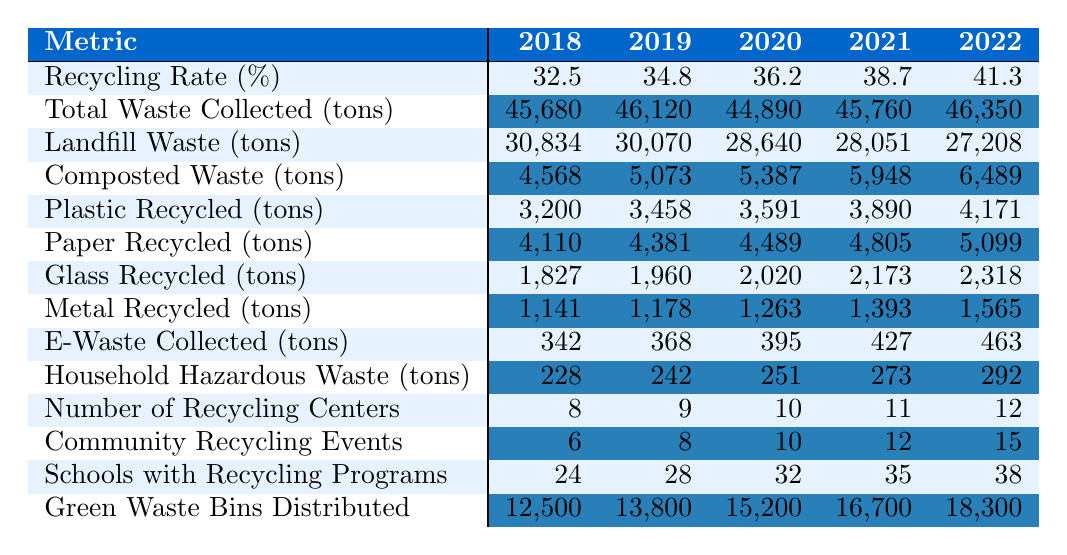What was the recycling rate in 2022? In the table, the recycling rate percentage for 2022 is listed as 41.3%.
Answer: 41.3% How much total waste was collected in 2020? The total waste collected in the year 2020 is listed as 44,890 tons.
Answer: 44,890 tons Did the amount of landfill waste decrease from 2018 to 2022? By comparing the landfill waste values for 2018 (30,834 tons) and 2022 (27,208 tons), it shows a decrease of 3,626 tons.
Answer: Yes What is the average recycling rate from 2018 to 2022? To find the average recycling rate, sum the rates (32.5 + 34.8 + 36.2 + 38.7 + 41.3 = 183.5) and divide by 5 (the number of years). This results in an average of 36.7%.
Answer: 36.7% How much plastic was recycled in total from 2018 to 2021? Summing the plastic recycled tons for the years 2018 (3,200), 2019 (3,458), 2020 (3,591), and 2021 (3,890) gives 3,200 + 3,458 + 3,591 + 3,890 = 14,139 tons.
Answer: 14,139 tons How many more recycling centers were there in 2022 compared to 2018? The number of recycling centers in 2022 was 12, and in 2018, it was 8. The difference is 12 - 8 = 4.
Answer: 4 What percentage of the total waste collected was composted in 2021? In 2021, the total waste collected was 45,760 tons and composted waste was 5,948 tons. The percentage is (5,948 / 45,760) * 100 ≈ 13.0%.
Answer: 13.0% Which year had the highest amount of E-Waste collected? The E-Waste collected amounts are listed as follows: 342 tons in 2018, 368 in 2019, 395 in 2020, 427 in 2021, and 463 in 2022. The highest amount is 463 tons in 2022.
Answer: 2022 If the trend continues, what might the estimated recycling rate be in 2023 assuming it increases linearly? The recycling rates are increasing by values of approximately 2.3% each year from 2018 to 2022. If this trend continues, the estimated rate for 2023 would be 41.3 + 2.3 = 43.6%.
Answer: 43.6% Was the amount of metal recycled in 2020 more or less than the amount of glass recycled that year? For 2020, the metal recycled was 1,263 tons and the glass recycled was 2,020 tons. Since 1,263 is less than 2,020, the statement is true.
Answer: Less 